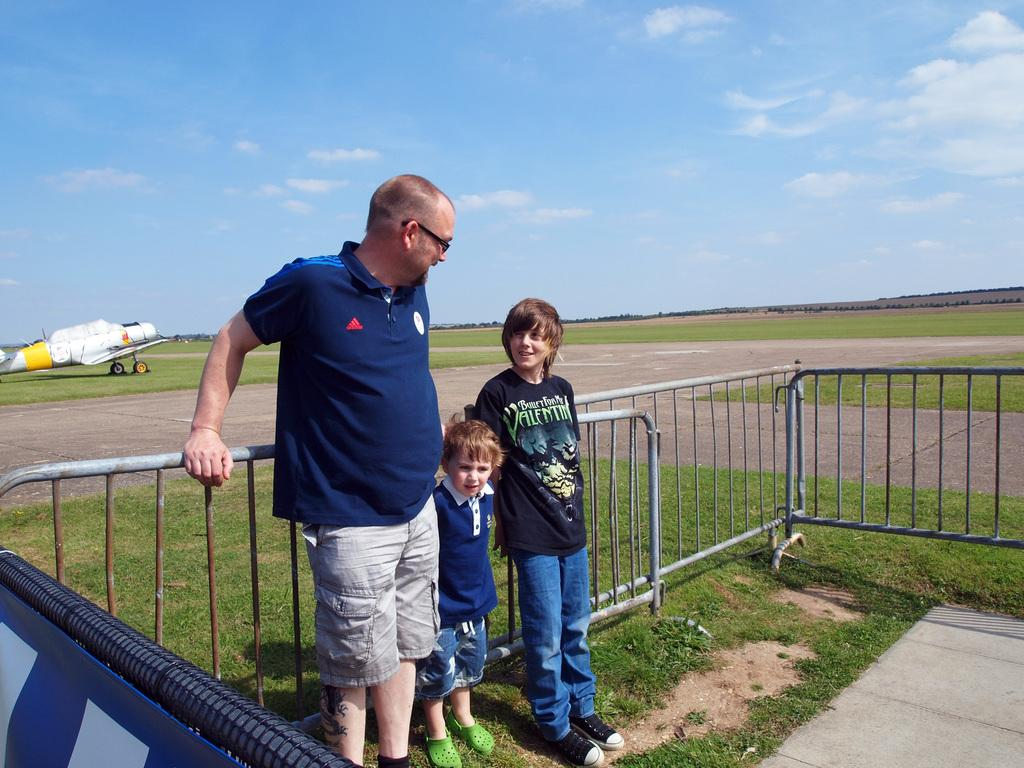Who is present in the image with the children? There is a man standing with the children in the image. What are the man and children holding? They are holding grills in the image. What can be seen in the background of the image? There are aircraft on the ground and roads visible in the background. What is the condition of the sky in the image? The sky is visible with clouds in the image. What type of sink is visible in the image? There is no sink present in the image. How does the brain of the man in the image appear? The image does not show the man's brain, so it cannot be described. 